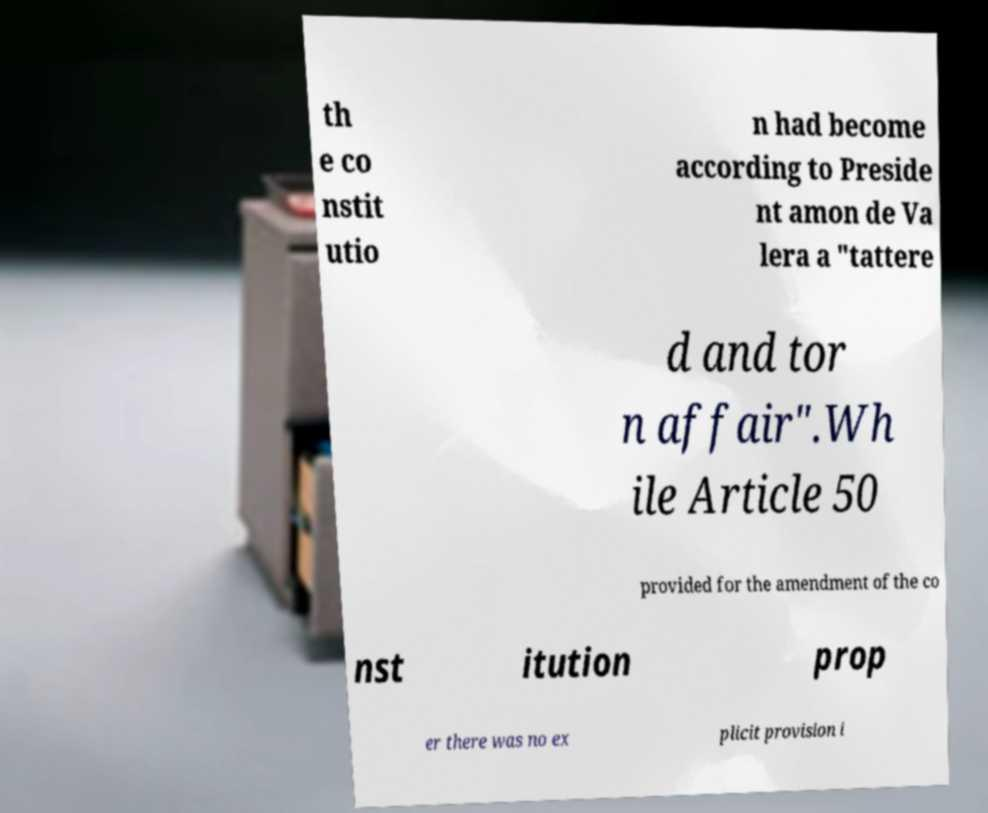Please identify and transcribe the text found in this image. th e co nstit utio n had become according to Preside nt amon de Va lera a "tattere d and tor n affair".Wh ile Article 50 provided for the amendment of the co nst itution prop er there was no ex plicit provision i 